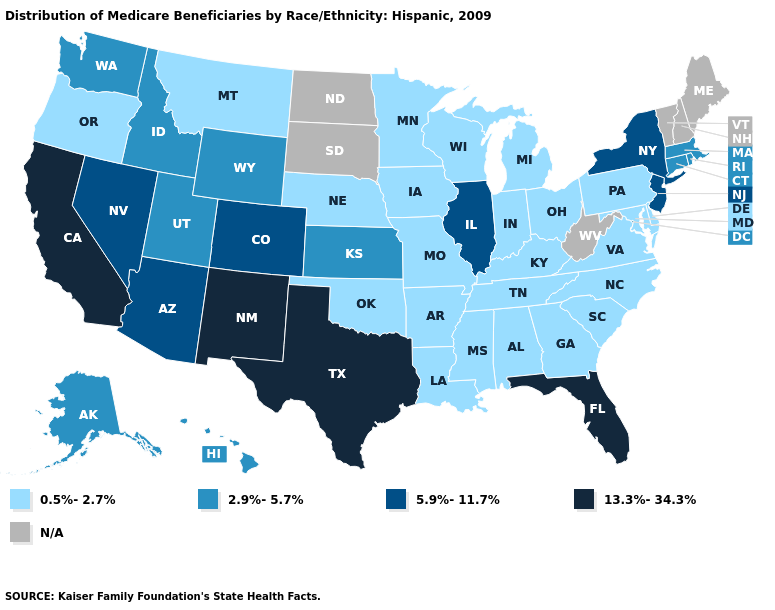Is the legend a continuous bar?
Be succinct. No. How many symbols are there in the legend?
Give a very brief answer. 5. Which states have the highest value in the USA?
Be succinct. California, Florida, New Mexico, Texas. What is the value of Oklahoma?
Give a very brief answer. 0.5%-2.7%. Name the states that have a value in the range 13.3%-34.3%?
Answer briefly. California, Florida, New Mexico, Texas. Name the states that have a value in the range 13.3%-34.3%?
Give a very brief answer. California, Florida, New Mexico, Texas. How many symbols are there in the legend?
Be succinct. 5. Name the states that have a value in the range 5.9%-11.7%?
Keep it brief. Arizona, Colorado, Illinois, Nevada, New Jersey, New York. What is the highest value in the USA?
Keep it brief. 13.3%-34.3%. What is the value of Oklahoma?
Keep it brief. 0.5%-2.7%. Name the states that have a value in the range 5.9%-11.7%?
Quick response, please. Arizona, Colorado, Illinois, Nevada, New Jersey, New York. Among the states that border Illinois , which have the highest value?
Keep it brief. Indiana, Iowa, Kentucky, Missouri, Wisconsin. Which states hav the highest value in the South?
Keep it brief. Florida, Texas. 